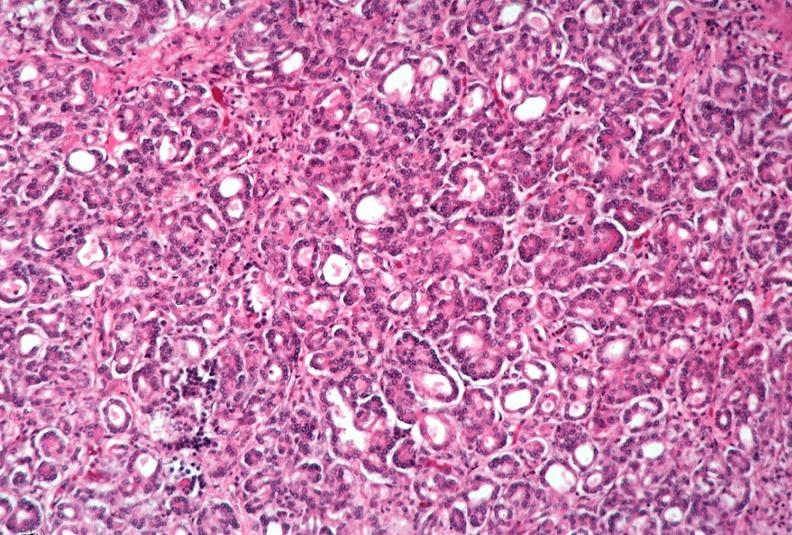does chromophobe adenoma show pancreas, uremic pancreatitis due to polycystic kidney?
Answer the question using a single word or phrase. No 